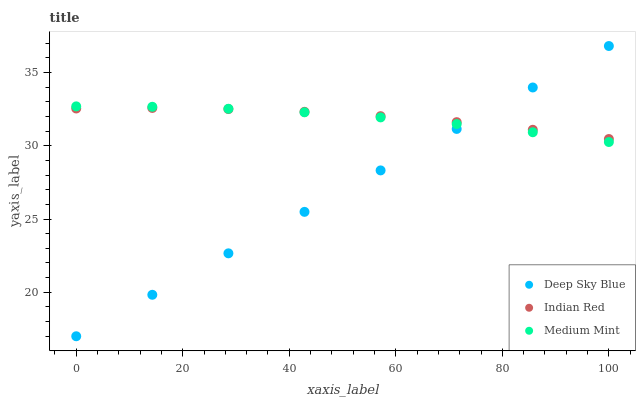Does Deep Sky Blue have the minimum area under the curve?
Answer yes or no. Yes. Does Indian Red have the maximum area under the curve?
Answer yes or no. Yes. Does Indian Red have the minimum area under the curve?
Answer yes or no. No. Does Deep Sky Blue have the maximum area under the curve?
Answer yes or no. No. Is Deep Sky Blue the smoothest?
Answer yes or no. Yes. Is Indian Red the roughest?
Answer yes or no. Yes. Is Indian Red the smoothest?
Answer yes or no. No. Is Deep Sky Blue the roughest?
Answer yes or no. No. Does Deep Sky Blue have the lowest value?
Answer yes or no. Yes. Does Indian Red have the lowest value?
Answer yes or no. No. Does Deep Sky Blue have the highest value?
Answer yes or no. Yes. Does Indian Red have the highest value?
Answer yes or no. No. Does Medium Mint intersect Deep Sky Blue?
Answer yes or no. Yes. Is Medium Mint less than Deep Sky Blue?
Answer yes or no. No. Is Medium Mint greater than Deep Sky Blue?
Answer yes or no. No. 